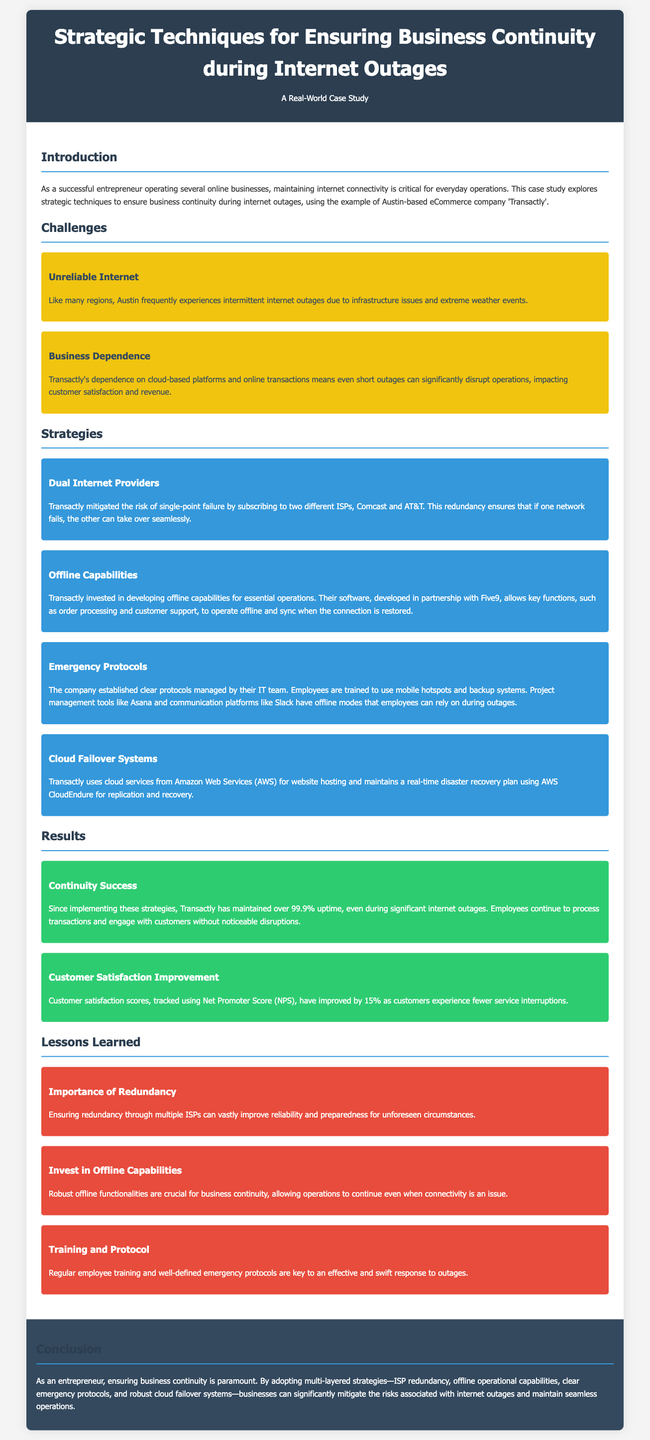What is the name of the company featured in the case study? The document refers to the company as 'Transactly'.
Answer: Transactly How often does Transactly maintain uptime? The document states that Transactly has maintained over 99.9% uptime.
Answer: 99.9% What are the names of the two ISPs used by Transactly? The case study mentions Comcast and AT&T as the ISPs.
Answer: Comcast and AT&T What percentage improvement did customer satisfaction scores achieve? The document indicates a 15% improvement in customer satisfaction scores.
Answer: 15% What type of systems does Transactly use for disaster recovery? The case study mentions AWS CloudEndure for replication and recovery.
Answer: AWS CloudEndure What protocol related to mobile hotspots was established by Transactly? The document illustrates that a protocol for using mobile hotspots was established.
Answer: Mobile hotspots What key functionality does Transactly's software provide during outages? The document states that key functions such as order processing can operate offline.
Answer: Order processing What is one important lesson learned from the case study? The case study emphasizes the importance of redundancy through multiple ISPs.
Answer: Importance of Redundancy How does Transactly track customer satisfaction? The document specifies that customer satisfaction is tracked using Net Promoter Score (NPS).
Answer: Net Promoter Score (NPS) 